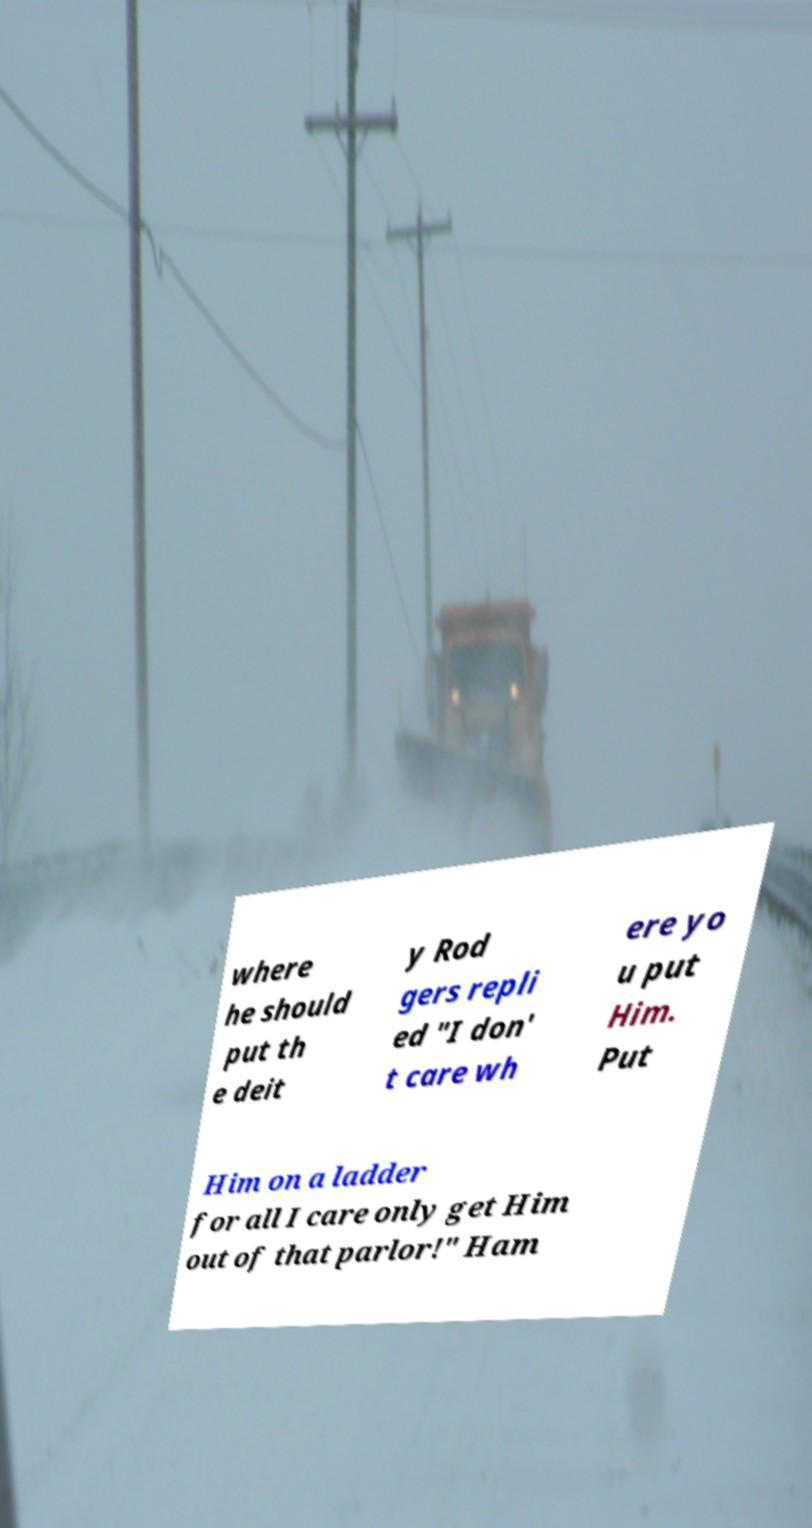Please read and relay the text visible in this image. What does it say? where he should put th e deit y Rod gers repli ed "I don' t care wh ere yo u put Him. Put Him on a ladder for all I care only get Him out of that parlor!" Ham 